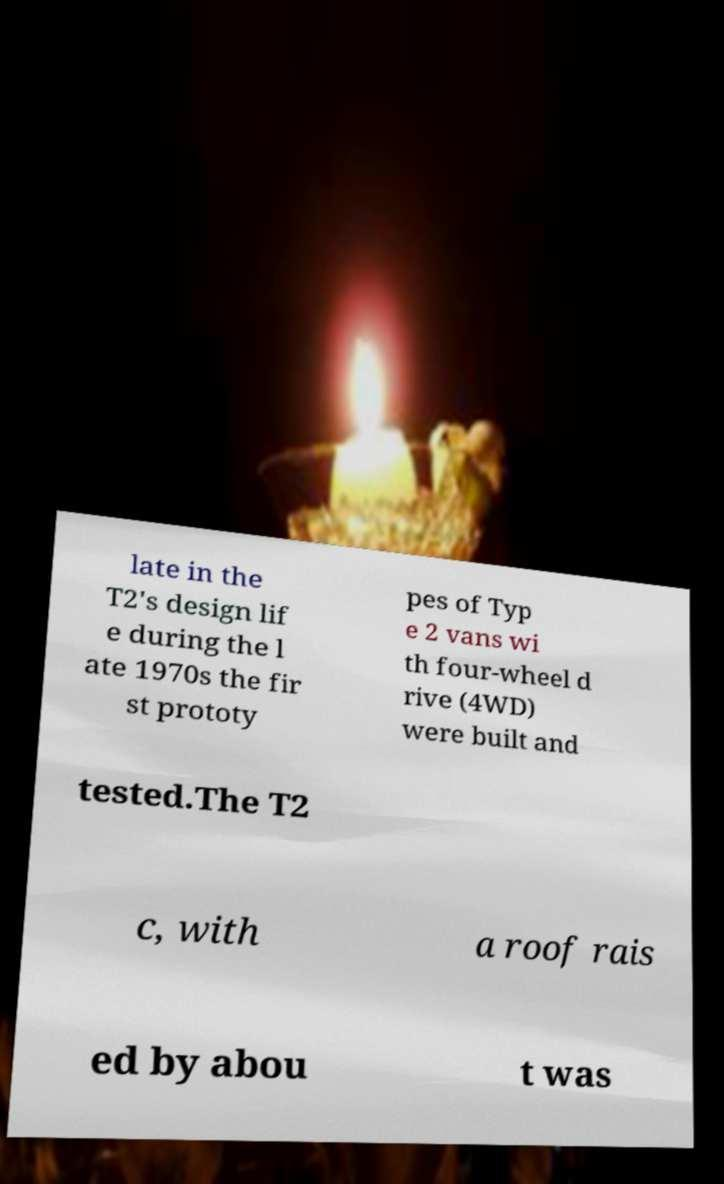Can you read and provide the text displayed in the image?This photo seems to have some interesting text. Can you extract and type it out for me? late in the T2's design lif e during the l ate 1970s the fir st prototy pes of Typ e 2 vans wi th four-wheel d rive (4WD) were built and tested.The T2 c, with a roof rais ed by abou t was 